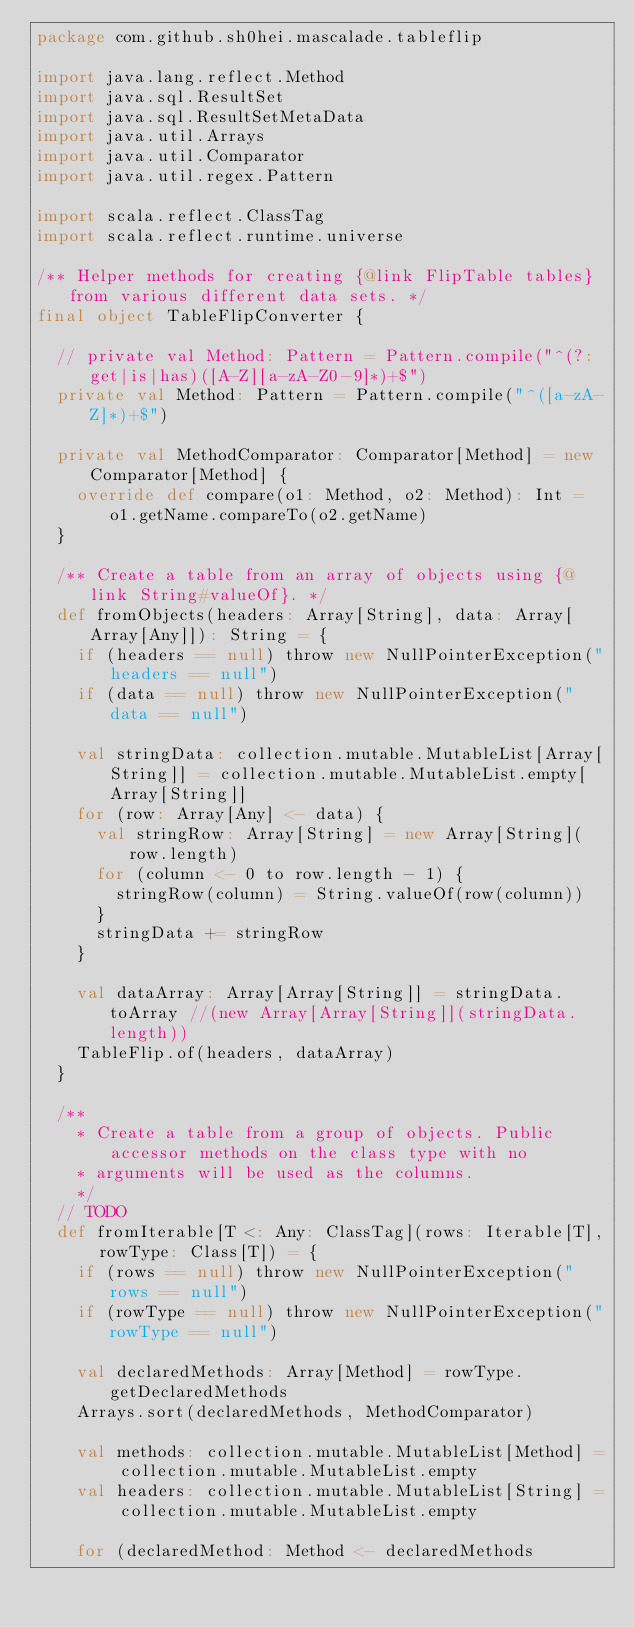<code> <loc_0><loc_0><loc_500><loc_500><_Scala_>package com.github.sh0hei.mascalade.tableflip

import java.lang.reflect.Method
import java.sql.ResultSet
import java.sql.ResultSetMetaData
import java.util.Arrays
import java.util.Comparator
import java.util.regex.Pattern

import scala.reflect.ClassTag
import scala.reflect.runtime.universe

/** Helper methods for creating {@link FlipTable tables} from various different data sets. */
final object TableFlipConverter {

  // private val Method: Pattern = Pattern.compile("^(?:get|is|has)([A-Z][a-zA-Z0-9]*)+$")
  private val Method: Pattern = Pattern.compile("^([a-zA-Z]*)+$")

  private val MethodComparator: Comparator[Method] = new Comparator[Method] {
    override def compare(o1: Method, o2: Method): Int = o1.getName.compareTo(o2.getName)
  }

  /** Create a table from an array of objects using {@link String#valueOf}. */
  def fromObjects(headers: Array[String], data: Array[Array[Any]]): String = {
    if (headers == null) throw new NullPointerException("headers == null")
    if (data == null) throw new NullPointerException("data == null")

    val stringData: collection.mutable.MutableList[Array[String]] = collection.mutable.MutableList.empty[Array[String]]
    for (row: Array[Any] <- data) {
      val stringRow: Array[String] = new Array[String](row.length)
      for (column <- 0 to row.length - 1) {
        stringRow(column) = String.valueOf(row(column))
      }
      stringData += stringRow
    }

    val dataArray: Array[Array[String]] = stringData.toArray //(new Array[Array[String]](stringData.length))
    TableFlip.of(headers, dataArray)
  }

  /**
    * Create a table from a group of objects. Public accessor methods on the class type with no
    * arguments will be used as the columns.
    */
  // TODO
  def fromIterable[T <: Any: ClassTag](rows: Iterable[T], rowType: Class[T]) = {
    if (rows == null) throw new NullPointerException("rows == null")
    if (rowType == null) throw new NullPointerException("rowType == null")

    val declaredMethods: Array[Method] = rowType.getDeclaredMethods
    Arrays.sort(declaredMethods, MethodComparator)

    val methods: collection.mutable.MutableList[Method] = collection.mutable.MutableList.empty
    val headers: collection.mutable.MutableList[String] = collection.mutable.MutableList.empty

    for (declaredMethod: Method <- declaredMethods</code> 